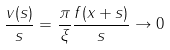<formula> <loc_0><loc_0><loc_500><loc_500>\frac { v ( s ) } { s } = \frac { \pi } { \xi } \frac { f ( x + s ) } { s } \to 0</formula> 